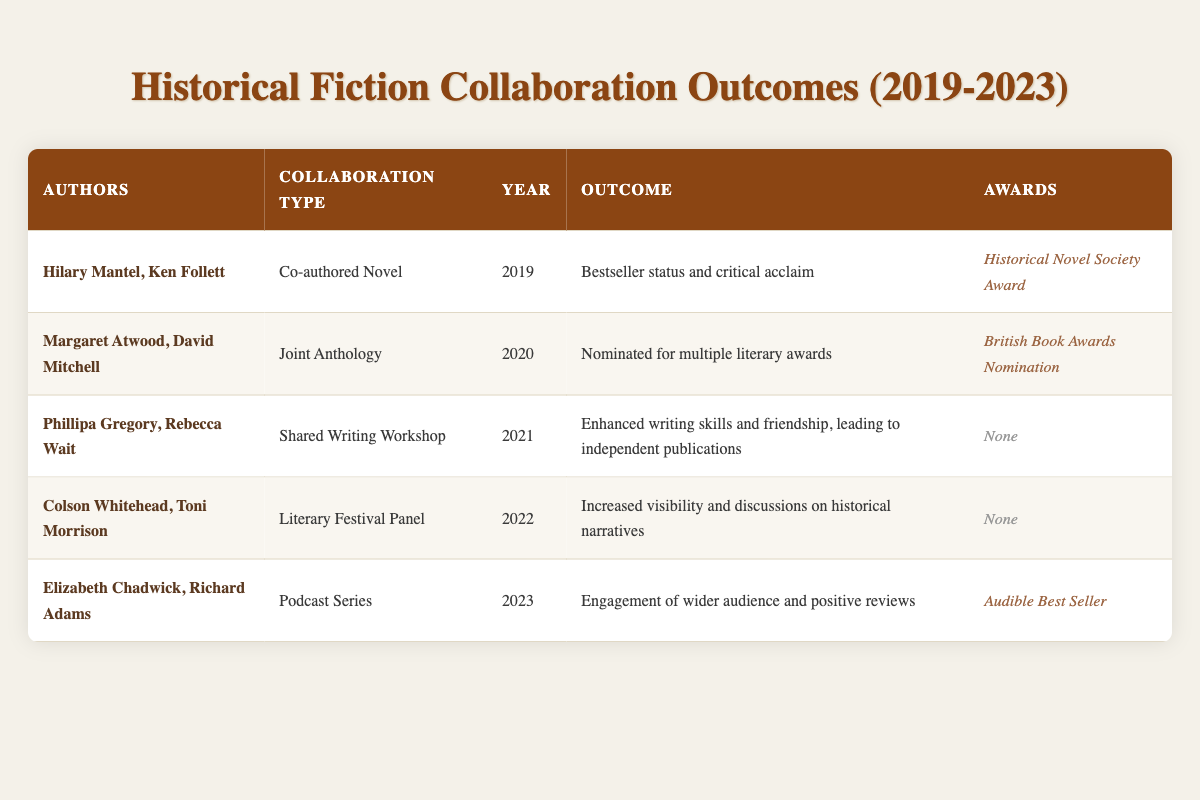What type of collaboration did Hilary Mantel and Ken Follett engage in? According to the table, Hilary Mantel and Ken Follett collaborated on a "Co-authored Novel." This can be directly observed in the respective row of the table.
Answer: Co-authored Novel In which year did Elizabeth Chadwick and Richard Adams collaborate? The table clearly indicates that Elizabeth Chadwick and Richard Adams collaborated in the year 2023, as seen in their row in the table.
Answer: 2023 How many collaborations resulted in awards? From the table, there are three entries that mention awards: the collaboration by Hilary Mantel and Ken Follett, Margaret Atwood and David Mitchell, and Elizabeth Chadwick and Richard Adams. Counting these rows gives a total of three collaborations with awards.
Answer: 3 Did Colson Whitehead and Toni Morrison’s collaboration lead to any awards? The table indicates that the collaboration between Colson Whitehead and Toni Morrison resulted in "None" for awards. This can be directly verified in the respective row of the table.
Answer: No Which collaboration had the outcome of "Bestseller status and critical acclaim"? Referring to the table, the collaboration that resulted in "Bestseller status and critical acclaim" is linked to Hilary Mantel and Ken Follett's "Co-authored Novel" from the year 2019. Thus, the direct lookup in the row provides this information.
Answer: Hilary Mantel and Ken Follett What is the total number of collaborations listed in the table? By counting the rows in the table, we can see that there are five distinct collaborations mentioned, each represented in their own respective row. Thus, the total number of collaborations is five.
Answer: 5 Which authors collaborated in 2021 and what was the outcome? The table shows that in 2021, Phillipa Gregory and Rebecca Wait collaborated through a "Shared Writing Workshop" with the outcome of "Enhanced writing skills and friendship, leading to independent publications." This information can be gathered by examining their specific row in the table.
Answer: Phillipa Gregory and Rebecca Wait; Enhanced writing skills and friendship, leading to independent publications Which collaboration type had the highest visibility in the year 2022? The table indicates that the collaboration type with the highest visibility in 2022 was a "Literary Festival Panel," as noted for Colson Whitehead and Toni Morrison. This can be inferred from both the collaboration type and the outcome elaborating on increased visibility.
Answer: Literary Festival Panel 